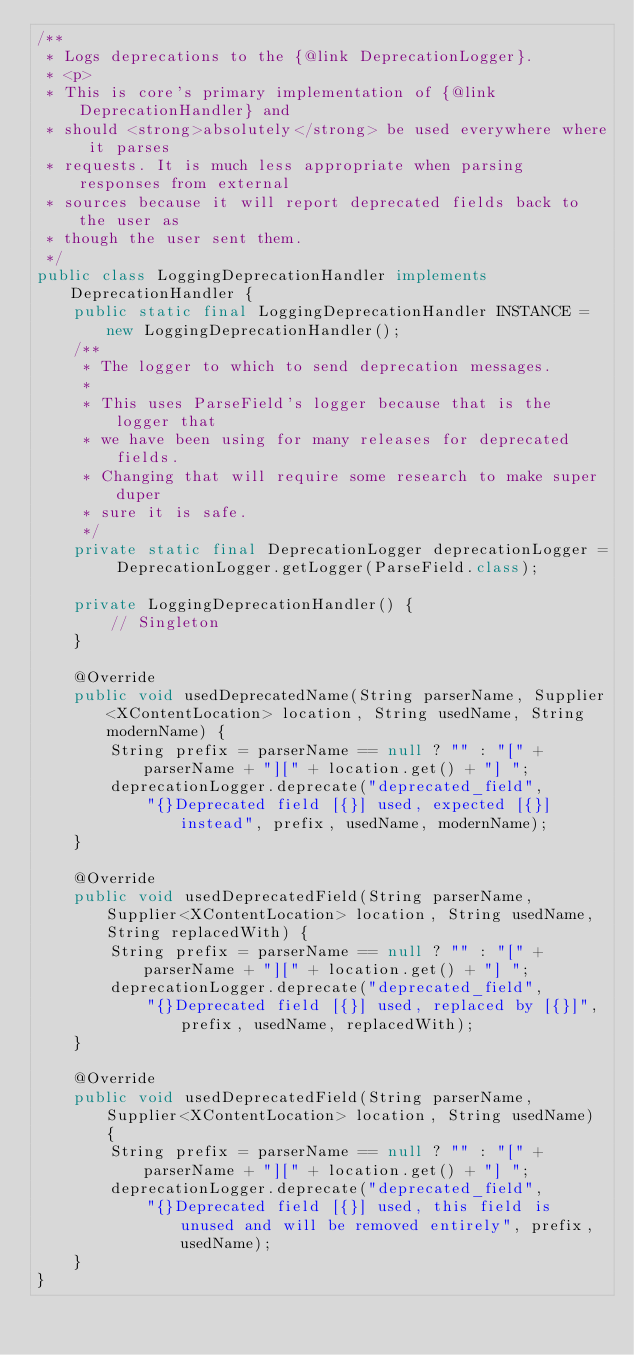<code> <loc_0><loc_0><loc_500><loc_500><_Java_>/**
 * Logs deprecations to the {@link DeprecationLogger}.
 * <p>
 * This is core's primary implementation of {@link DeprecationHandler} and
 * should <strong>absolutely</strong> be used everywhere where it parses
 * requests. It is much less appropriate when parsing responses from external
 * sources because it will report deprecated fields back to the user as
 * though the user sent them.
 */
public class LoggingDeprecationHandler implements DeprecationHandler {
    public static final LoggingDeprecationHandler INSTANCE = new LoggingDeprecationHandler();
    /**
     * The logger to which to send deprecation messages.
     *
     * This uses ParseField's logger because that is the logger that
     * we have been using for many releases for deprecated fields.
     * Changing that will require some research to make super duper
     * sure it is safe.
     */
    private static final DeprecationLogger deprecationLogger = DeprecationLogger.getLogger(ParseField.class);

    private LoggingDeprecationHandler() {
        // Singleton
    }

    @Override
    public void usedDeprecatedName(String parserName, Supplier<XContentLocation> location, String usedName, String modernName) {
        String prefix = parserName == null ? "" : "[" + parserName + "][" + location.get() + "] ";
        deprecationLogger.deprecate("deprecated_field",
            "{}Deprecated field [{}] used, expected [{}] instead", prefix, usedName, modernName);
    }

    @Override
    public void usedDeprecatedField(String parserName, Supplier<XContentLocation> location, String usedName, String replacedWith) {
        String prefix = parserName == null ? "" : "[" + parserName + "][" + location.get() + "] ";
        deprecationLogger.deprecate("deprecated_field",
            "{}Deprecated field [{}] used, replaced by [{}]", prefix, usedName, replacedWith);
    }

    @Override
    public void usedDeprecatedField(String parserName, Supplier<XContentLocation> location, String usedName) {
        String prefix = parserName == null ? "" : "[" + parserName + "][" + location.get() + "] ";
        deprecationLogger.deprecate("deprecated_field",
            "{}Deprecated field [{}] used, this field is unused and will be removed entirely", prefix, usedName);
    }
}
</code> 